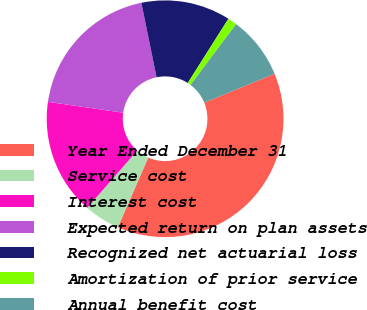Convert chart to OTSL. <chart><loc_0><loc_0><loc_500><loc_500><pie_chart><fcel>Year Ended December 31<fcel>Service cost<fcel>Interest cost<fcel>Expected return on plan assets<fcel>Recognized net actuarial loss<fcel>Amortization of prior service<fcel>Annual benefit cost<nl><fcel>37.74%<fcel>4.9%<fcel>15.85%<fcel>19.5%<fcel>12.2%<fcel>1.26%<fcel>8.55%<nl></chart> 